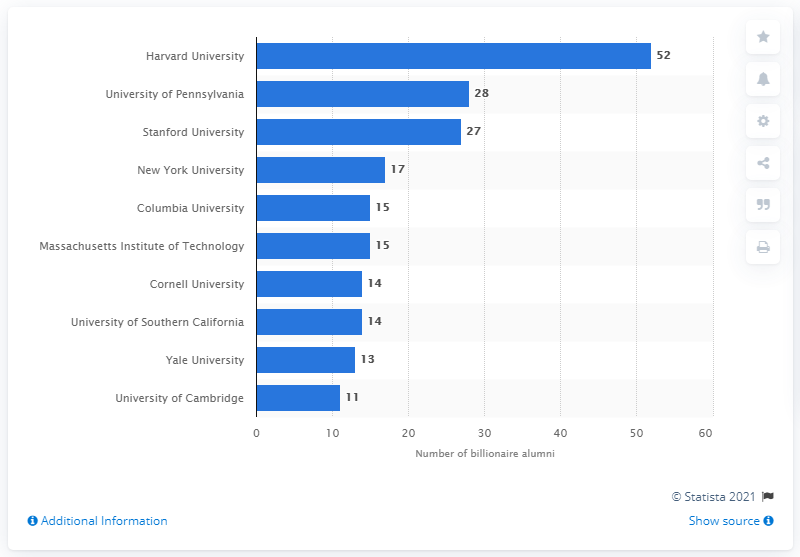List a handful of essential elements in this visual. As of 2013, Harvard had 52 billionaire alumni. 